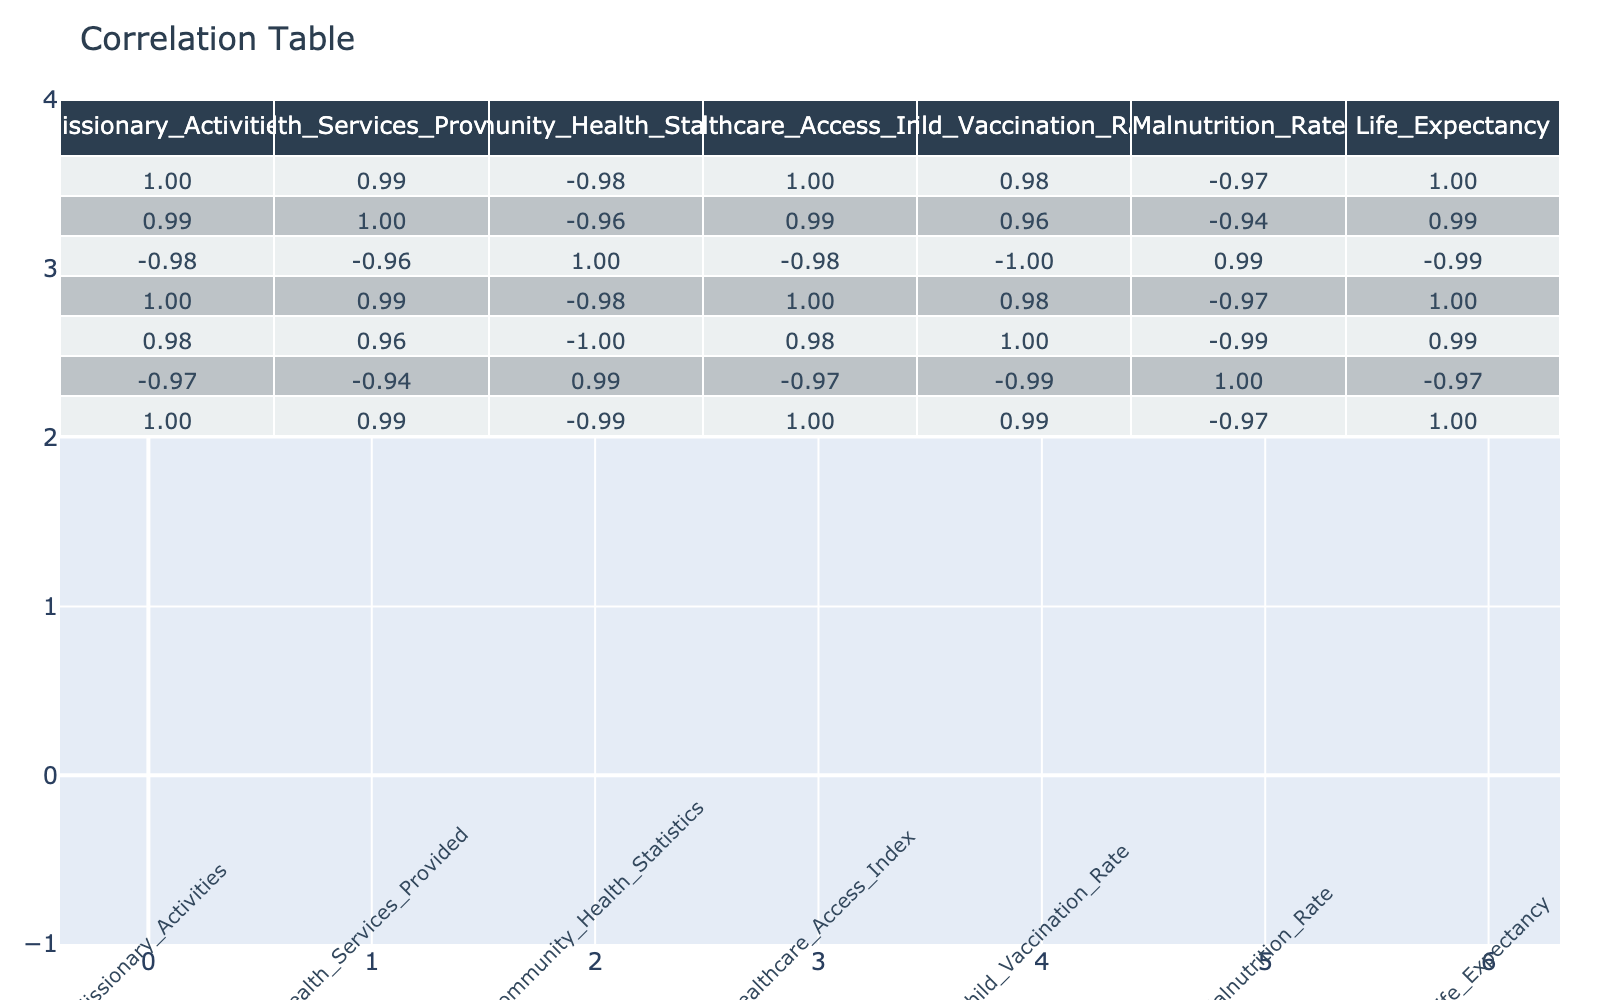What is the correlation between Missionary Activities and Child Vaccination Rate? The correlation table shows the correlation coefficient value between Missionary Activities and Child Vaccination Rate, which is approximately 0.89. This indicates a strong positive correlation, meaning that as missionary activities increase, the child vaccination rate also tends to increase.
Answer: 0.89 What is the average Life Expectancy from the data provided? To find the average Life Expectancy, I will add each Life Expectancy value and divide by the number of data points: (68 + 70 + 65 + 72 + 63) / 5 = 67.6.
Answer: 67.6 Is there a negative correlation between Malnutrition Rate and Healthcare Access Index? The correlation coefficient between Malnutrition Rate and Healthcare Access Index is -0.87, indicating a strong negative correlation. Thus, higher healthcare access correlates with lower malnutrition rates.
Answer: Yes What is the difference in Community Health Statistics between the rows with the maximum and minimum Healthcare Access Index? The maximum Healthcare Access Index is 0.85 (Row 4) and the minimum is 0.65 (Row 5). The corresponding Community Health Statistics are 25 and 40, respectively. The difference is 40 - 25 = 15.
Answer: 15 If there are 5 missionary activities leading to 85% child vaccination rate, would 300 missionary activities correlate to a higher rate? By observing the correlation coefficient of 0.89 between Missionary Activities and Child Vaccination Rate, it can be inferred that as missionary activities increase, the child vaccination rate is likely to rise as well, suggesting that 300 missionary activities would likely correlate to a higher vaccination rate compared to 5 activities.
Answer: Yes 